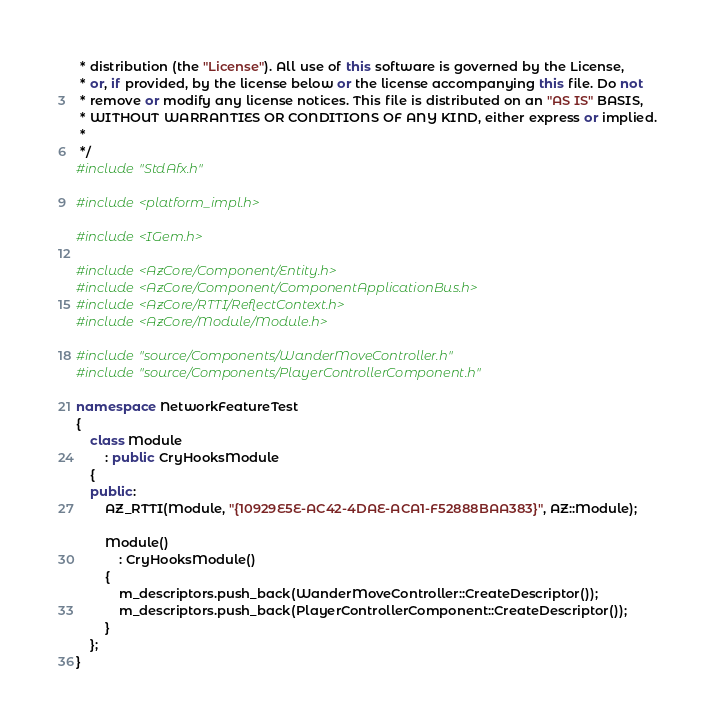<code> <loc_0><loc_0><loc_500><loc_500><_C++_> * distribution (the "License"). All use of this software is governed by the License,
 * or, if provided, by the license below or the license accompanying this file. Do not
 * remove or modify any license notices. This file is distributed on an "AS IS" BASIS,
 * WITHOUT WARRANTIES OR CONDITIONS OF ANY KIND, either express or implied.
 *
 */
#include "StdAfx.h"

#include <platform_impl.h>

#include <IGem.h>

#include <AzCore/Component/Entity.h>
#include <AzCore/Component/ComponentApplicationBus.h>
#include <AzCore/RTTI/ReflectContext.h>
#include <AzCore/Module/Module.h>

#include "source/Components/WanderMoveController.h"
#include "source/Components/PlayerControllerComponent.h"

namespace NetworkFeatureTest
{
    class Module
        : public CryHooksModule
    {
    public:
        AZ_RTTI(Module, "{10929E5E-AC42-4DAE-ACA1-F52888BAA383}", AZ::Module);

        Module()
            : CryHooksModule()
        {
            m_descriptors.push_back(WanderMoveController::CreateDescriptor());
            m_descriptors.push_back(PlayerControllerComponent::CreateDescriptor());
        }
    };
}
</code> 